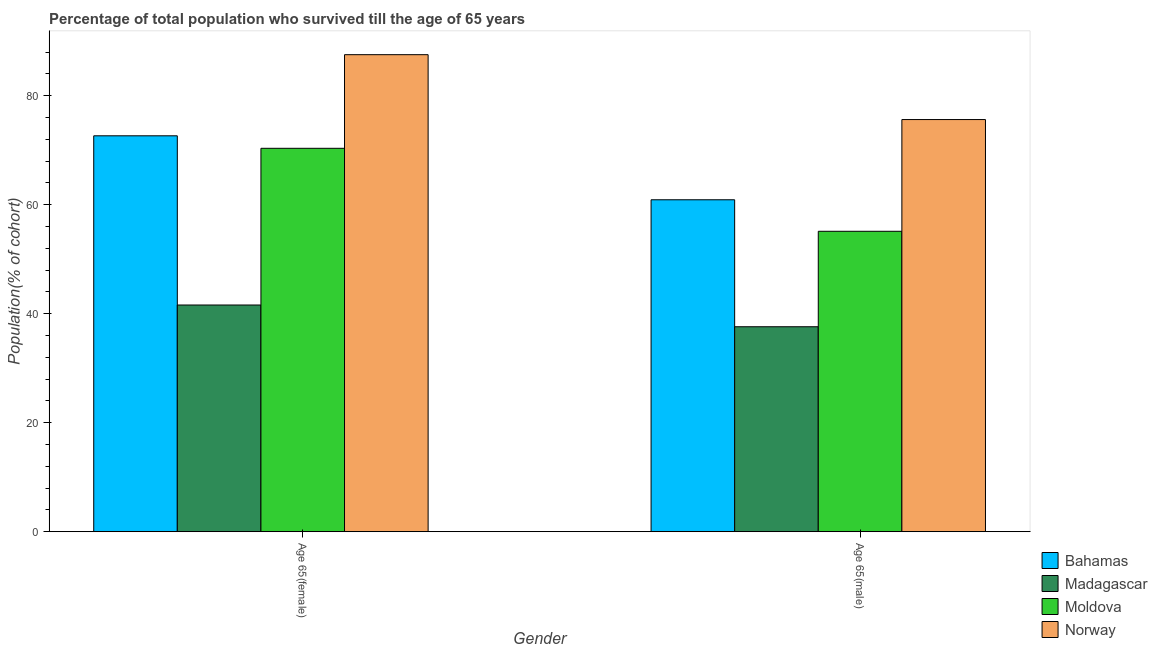How many groups of bars are there?
Your response must be concise. 2. Are the number of bars per tick equal to the number of legend labels?
Offer a terse response. Yes. How many bars are there on the 1st tick from the right?
Your response must be concise. 4. What is the label of the 1st group of bars from the left?
Provide a succinct answer. Age 65(female). What is the percentage of female population who survived till age of 65 in Norway?
Provide a short and direct response. 87.53. Across all countries, what is the maximum percentage of female population who survived till age of 65?
Provide a succinct answer. 87.53. Across all countries, what is the minimum percentage of female population who survived till age of 65?
Keep it short and to the point. 41.6. In which country was the percentage of male population who survived till age of 65 maximum?
Provide a short and direct response. Norway. In which country was the percentage of male population who survived till age of 65 minimum?
Offer a terse response. Madagascar. What is the total percentage of female population who survived till age of 65 in the graph?
Your answer should be compact. 272.12. What is the difference between the percentage of male population who survived till age of 65 in Bahamas and that in Moldova?
Make the answer very short. 5.78. What is the difference between the percentage of female population who survived till age of 65 in Madagascar and the percentage of male population who survived till age of 65 in Bahamas?
Your answer should be compact. -19.31. What is the average percentage of female population who survived till age of 65 per country?
Make the answer very short. 68.03. What is the difference between the percentage of male population who survived till age of 65 and percentage of female population who survived till age of 65 in Moldova?
Keep it short and to the point. -15.23. What is the ratio of the percentage of male population who survived till age of 65 in Norway to that in Moldova?
Your answer should be compact. 1.37. Is the percentage of male population who survived till age of 65 in Madagascar less than that in Bahamas?
Give a very brief answer. Yes. What does the 1st bar from the left in Age 65(female) represents?
Offer a very short reply. Bahamas. What does the 3rd bar from the right in Age 65(female) represents?
Your answer should be very brief. Madagascar. Are all the bars in the graph horizontal?
Ensure brevity in your answer.  No. Are the values on the major ticks of Y-axis written in scientific E-notation?
Give a very brief answer. No. Does the graph contain grids?
Offer a very short reply. No. Where does the legend appear in the graph?
Offer a very short reply. Bottom right. How are the legend labels stacked?
Keep it short and to the point. Vertical. What is the title of the graph?
Give a very brief answer. Percentage of total population who survived till the age of 65 years. Does "Ghana" appear as one of the legend labels in the graph?
Make the answer very short. No. What is the label or title of the X-axis?
Offer a terse response. Gender. What is the label or title of the Y-axis?
Ensure brevity in your answer.  Population(% of cohort). What is the Population(% of cohort) in Bahamas in Age 65(female)?
Your response must be concise. 72.64. What is the Population(% of cohort) in Madagascar in Age 65(female)?
Provide a succinct answer. 41.6. What is the Population(% of cohort) of Moldova in Age 65(female)?
Your answer should be very brief. 70.35. What is the Population(% of cohort) in Norway in Age 65(female)?
Provide a succinct answer. 87.53. What is the Population(% of cohort) in Bahamas in Age 65(male)?
Your answer should be very brief. 60.91. What is the Population(% of cohort) of Madagascar in Age 65(male)?
Make the answer very short. 37.61. What is the Population(% of cohort) in Moldova in Age 65(male)?
Provide a short and direct response. 55.12. What is the Population(% of cohort) of Norway in Age 65(male)?
Ensure brevity in your answer.  75.62. Across all Gender, what is the maximum Population(% of cohort) in Bahamas?
Provide a succinct answer. 72.64. Across all Gender, what is the maximum Population(% of cohort) of Madagascar?
Give a very brief answer. 41.6. Across all Gender, what is the maximum Population(% of cohort) in Moldova?
Your response must be concise. 70.35. Across all Gender, what is the maximum Population(% of cohort) in Norway?
Make the answer very short. 87.53. Across all Gender, what is the minimum Population(% of cohort) of Bahamas?
Provide a short and direct response. 60.91. Across all Gender, what is the minimum Population(% of cohort) in Madagascar?
Keep it short and to the point. 37.61. Across all Gender, what is the minimum Population(% of cohort) of Moldova?
Your response must be concise. 55.12. Across all Gender, what is the minimum Population(% of cohort) of Norway?
Your answer should be very brief. 75.62. What is the total Population(% of cohort) of Bahamas in the graph?
Your answer should be very brief. 133.55. What is the total Population(% of cohort) in Madagascar in the graph?
Give a very brief answer. 79.2. What is the total Population(% of cohort) of Moldova in the graph?
Offer a terse response. 125.47. What is the total Population(% of cohort) of Norway in the graph?
Your answer should be very brief. 163.15. What is the difference between the Population(% of cohort) of Bahamas in Age 65(female) and that in Age 65(male)?
Make the answer very short. 11.74. What is the difference between the Population(% of cohort) in Madagascar in Age 65(female) and that in Age 65(male)?
Offer a terse response. 3.99. What is the difference between the Population(% of cohort) in Moldova in Age 65(female) and that in Age 65(male)?
Ensure brevity in your answer.  15.23. What is the difference between the Population(% of cohort) of Norway in Age 65(female) and that in Age 65(male)?
Your response must be concise. 11.9. What is the difference between the Population(% of cohort) in Bahamas in Age 65(female) and the Population(% of cohort) in Madagascar in Age 65(male)?
Keep it short and to the point. 35.04. What is the difference between the Population(% of cohort) in Bahamas in Age 65(female) and the Population(% of cohort) in Moldova in Age 65(male)?
Your answer should be very brief. 17.52. What is the difference between the Population(% of cohort) of Bahamas in Age 65(female) and the Population(% of cohort) of Norway in Age 65(male)?
Your answer should be compact. -2.98. What is the difference between the Population(% of cohort) in Madagascar in Age 65(female) and the Population(% of cohort) in Moldova in Age 65(male)?
Keep it short and to the point. -13.53. What is the difference between the Population(% of cohort) in Madagascar in Age 65(female) and the Population(% of cohort) in Norway in Age 65(male)?
Your response must be concise. -34.03. What is the difference between the Population(% of cohort) in Moldova in Age 65(female) and the Population(% of cohort) in Norway in Age 65(male)?
Offer a very short reply. -5.28. What is the average Population(% of cohort) in Bahamas per Gender?
Your response must be concise. 66.77. What is the average Population(% of cohort) of Madagascar per Gender?
Provide a succinct answer. 39.6. What is the average Population(% of cohort) in Moldova per Gender?
Provide a short and direct response. 62.74. What is the average Population(% of cohort) in Norway per Gender?
Your answer should be compact. 81.58. What is the difference between the Population(% of cohort) of Bahamas and Population(% of cohort) of Madagascar in Age 65(female)?
Your response must be concise. 31.05. What is the difference between the Population(% of cohort) in Bahamas and Population(% of cohort) in Moldova in Age 65(female)?
Make the answer very short. 2.29. What is the difference between the Population(% of cohort) of Bahamas and Population(% of cohort) of Norway in Age 65(female)?
Provide a short and direct response. -14.88. What is the difference between the Population(% of cohort) of Madagascar and Population(% of cohort) of Moldova in Age 65(female)?
Your response must be concise. -28.75. What is the difference between the Population(% of cohort) in Madagascar and Population(% of cohort) in Norway in Age 65(female)?
Provide a succinct answer. -45.93. What is the difference between the Population(% of cohort) of Moldova and Population(% of cohort) of Norway in Age 65(female)?
Your answer should be compact. -17.18. What is the difference between the Population(% of cohort) of Bahamas and Population(% of cohort) of Madagascar in Age 65(male)?
Keep it short and to the point. 23.3. What is the difference between the Population(% of cohort) of Bahamas and Population(% of cohort) of Moldova in Age 65(male)?
Ensure brevity in your answer.  5.78. What is the difference between the Population(% of cohort) in Bahamas and Population(% of cohort) in Norway in Age 65(male)?
Ensure brevity in your answer.  -14.72. What is the difference between the Population(% of cohort) of Madagascar and Population(% of cohort) of Moldova in Age 65(male)?
Give a very brief answer. -17.52. What is the difference between the Population(% of cohort) in Madagascar and Population(% of cohort) in Norway in Age 65(male)?
Keep it short and to the point. -38.02. What is the difference between the Population(% of cohort) of Moldova and Population(% of cohort) of Norway in Age 65(male)?
Provide a short and direct response. -20.5. What is the ratio of the Population(% of cohort) in Bahamas in Age 65(female) to that in Age 65(male)?
Make the answer very short. 1.19. What is the ratio of the Population(% of cohort) of Madagascar in Age 65(female) to that in Age 65(male)?
Your answer should be compact. 1.11. What is the ratio of the Population(% of cohort) in Moldova in Age 65(female) to that in Age 65(male)?
Your response must be concise. 1.28. What is the ratio of the Population(% of cohort) in Norway in Age 65(female) to that in Age 65(male)?
Ensure brevity in your answer.  1.16. What is the difference between the highest and the second highest Population(% of cohort) in Bahamas?
Provide a succinct answer. 11.74. What is the difference between the highest and the second highest Population(% of cohort) in Madagascar?
Provide a short and direct response. 3.99. What is the difference between the highest and the second highest Population(% of cohort) in Moldova?
Offer a very short reply. 15.23. What is the difference between the highest and the second highest Population(% of cohort) of Norway?
Keep it short and to the point. 11.9. What is the difference between the highest and the lowest Population(% of cohort) in Bahamas?
Keep it short and to the point. 11.74. What is the difference between the highest and the lowest Population(% of cohort) of Madagascar?
Offer a terse response. 3.99. What is the difference between the highest and the lowest Population(% of cohort) of Moldova?
Ensure brevity in your answer.  15.23. What is the difference between the highest and the lowest Population(% of cohort) in Norway?
Provide a short and direct response. 11.9. 